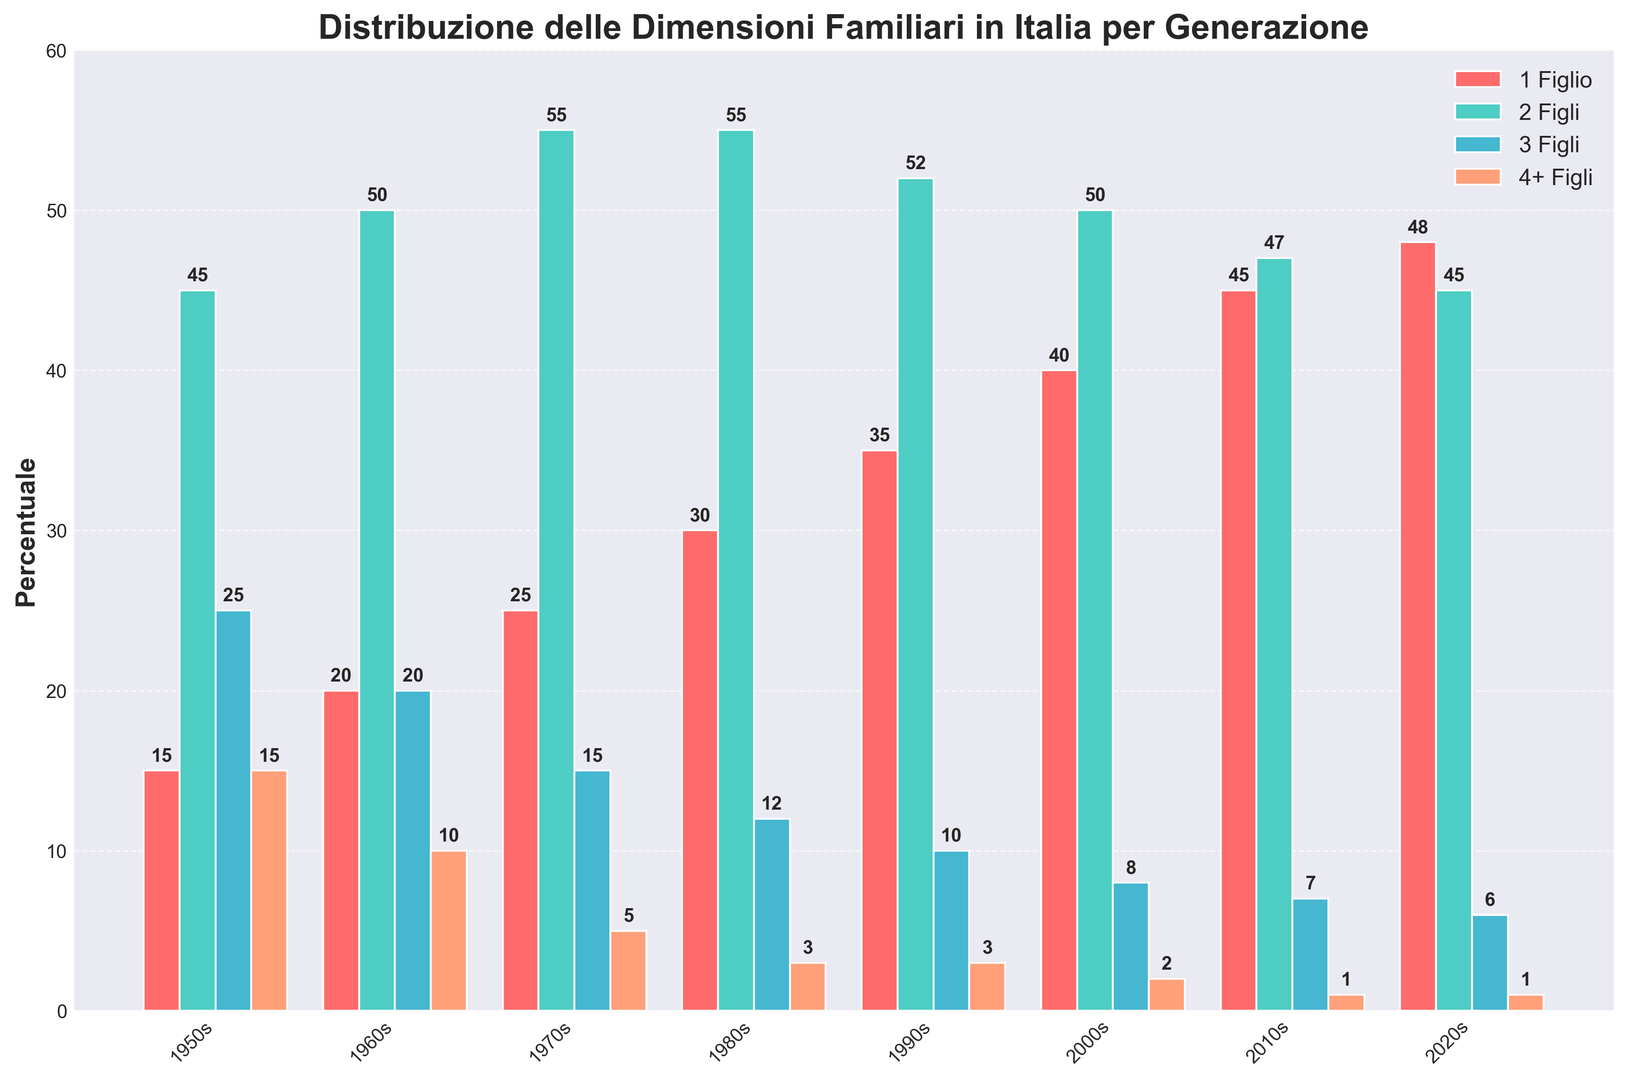What is the percentage of 1-child families in the 1950s and 2020s combined? In the 1950s, the percentage is 15%, and in the 2020s, it is 48%. To get the combined percentage, add these two values: 15 + 48 = 63.
Answer: 63% Has the percentage of families with 2 children increased or decreased from the 1950s to the 2020s? The percentage of families with 2 children in the 1950s is 45%, and in the 2020s, it is 45%. It has remained the same.
Answer: Remained the same Which generation had the highest percentage of 3-child families, and what was the percentage? Checking the bar heights for 3-child families across all generations, the 1950s had the highest at 25%.
Answer: 1950s, 25% Compare the percentage of families with 4+ children from the 1950s to the 2020s. How has it changed? The percentage in the 1950s is 15%, and in the 2020s, it is 1%. So, it has decreased by 14 percentage points.
Answer: Decreased by 14% Identify the trend for 1-child families from the 1950s to the 2020s. Observing the heights of the bars for 1-child families, the percentage consistently increases from one generation to the next.
Answer: Increasing trend Which generation had the greatest percentage of families with 2 children, and what was the percentage? Analyzing the bar heights for 2-child families, the 1970s and 1980s both have the highest at 55%.
Answer: 1970s and 1980s, 55% What is the total percentage for 2-children and 3-children families combined in the 1960s? In the 1960s, the percentage for 2-children families is 50% and for 3-children families is 20%. Combining these: 50 + 20 = 70.
Answer: 70% How does the percentage of families with 1 child in the 2010s compare to that in the 2000s? In the 2000s, the percentage is 40%, and in the 2010s, it is 45%. Thus, it increased by 5 percentage points.
Answer: Increased by 5% What percentage of families had children in the 4+ category in the 1980s and 1990s? In the 1980s, the percentage for 4+ children is 3%, and in the 1990s it is also 3%. Adding these: 3 + 3 = 6.
Answer: 6% 